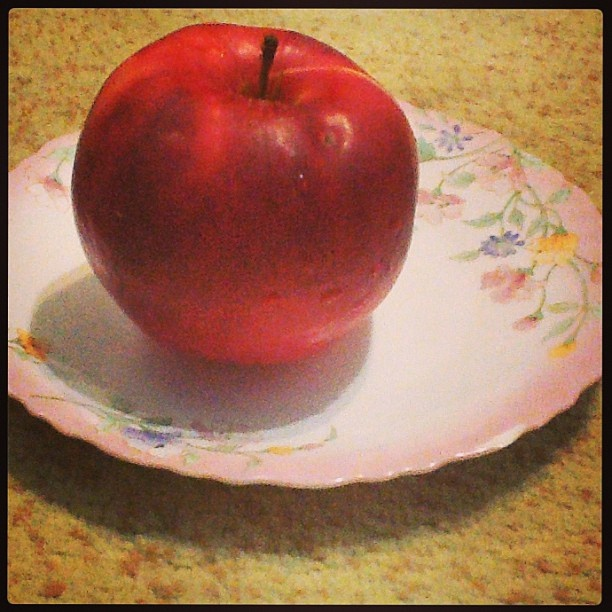Describe the objects in this image and their specific colors. I can see a apple in black, maroon, brown, and red tones in this image. 